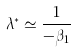Convert formula to latex. <formula><loc_0><loc_0><loc_500><loc_500>\lambda ^ { * } \simeq \frac { 1 } { - \beta _ { 1 } }</formula> 